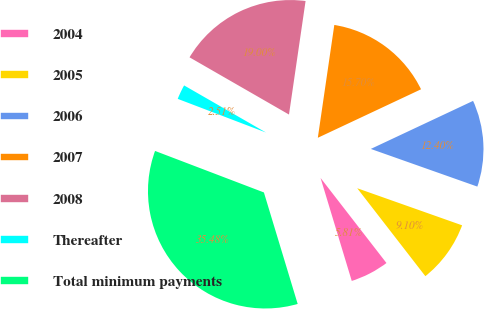<chart> <loc_0><loc_0><loc_500><loc_500><pie_chart><fcel>2004<fcel>2005<fcel>2006<fcel>2007<fcel>2008<fcel>Thereafter<fcel>Total minimum payments<nl><fcel>5.81%<fcel>9.1%<fcel>12.4%<fcel>15.7%<fcel>19.0%<fcel>2.51%<fcel>35.48%<nl></chart> 